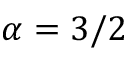<formula> <loc_0><loc_0><loc_500><loc_500>\alpha = 3 / 2</formula> 